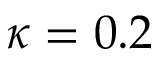<formula> <loc_0><loc_0><loc_500><loc_500>\kappa = 0 . 2</formula> 